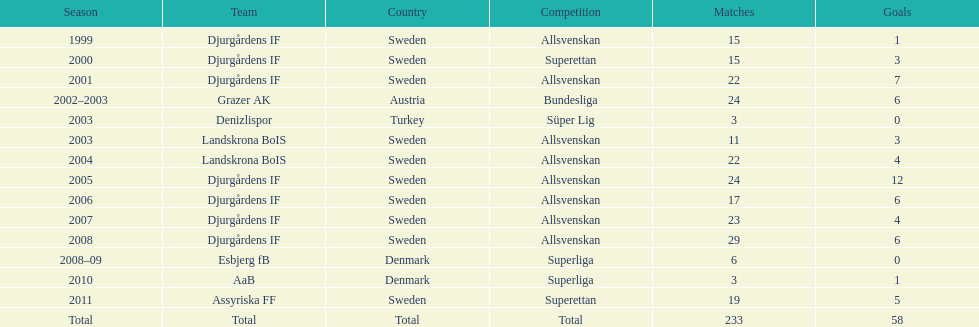From which country does team djurgårdens not originate? Sweden. 